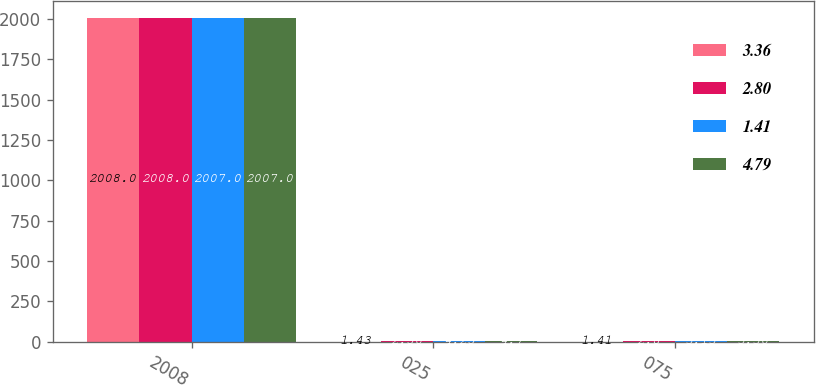<chart> <loc_0><loc_0><loc_500><loc_500><stacked_bar_chart><ecel><fcel>2008<fcel>025<fcel>075<nl><fcel>3.36<fcel>2008<fcel>1.43<fcel>1.41<nl><fcel>2.8<fcel>2008<fcel>2.56<fcel>2.8<nl><fcel>1.41<fcel>2007<fcel>4.25<fcel>3.13<nl><fcel>4.79<fcel>2007<fcel>4.7<fcel>3.36<nl></chart> 